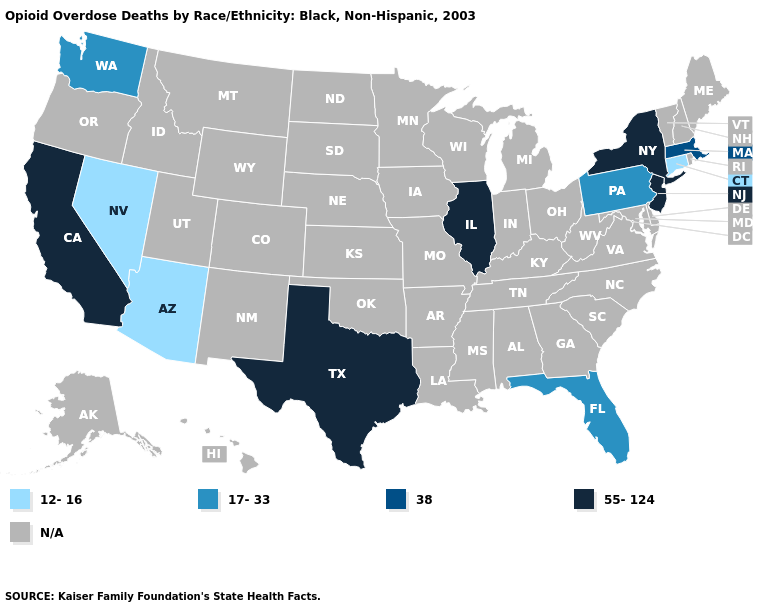Does Texas have the highest value in the South?
Keep it brief. Yes. Name the states that have a value in the range N/A?
Keep it brief. Alabama, Alaska, Arkansas, Colorado, Delaware, Georgia, Hawaii, Idaho, Indiana, Iowa, Kansas, Kentucky, Louisiana, Maine, Maryland, Michigan, Minnesota, Mississippi, Missouri, Montana, Nebraska, New Hampshire, New Mexico, North Carolina, North Dakota, Ohio, Oklahoma, Oregon, Rhode Island, South Carolina, South Dakota, Tennessee, Utah, Vermont, Virginia, West Virginia, Wisconsin, Wyoming. Name the states that have a value in the range 12-16?
Concise answer only. Arizona, Connecticut, Nevada. What is the highest value in states that border Massachusetts?
Keep it brief. 55-124. Name the states that have a value in the range 55-124?
Answer briefly. California, Illinois, New Jersey, New York, Texas. Does the map have missing data?
Give a very brief answer. Yes. What is the value of Wisconsin?
Write a very short answer. N/A. Name the states that have a value in the range N/A?
Give a very brief answer. Alabama, Alaska, Arkansas, Colorado, Delaware, Georgia, Hawaii, Idaho, Indiana, Iowa, Kansas, Kentucky, Louisiana, Maine, Maryland, Michigan, Minnesota, Mississippi, Missouri, Montana, Nebraska, New Hampshire, New Mexico, North Carolina, North Dakota, Ohio, Oklahoma, Oregon, Rhode Island, South Carolina, South Dakota, Tennessee, Utah, Vermont, Virginia, West Virginia, Wisconsin, Wyoming. Which states have the lowest value in the USA?
Concise answer only. Arizona, Connecticut, Nevada. What is the value of Nebraska?
Quick response, please. N/A. What is the highest value in the USA?
Short answer required. 55-124. What is the value of Michigan?
Be succinct. N/A. 